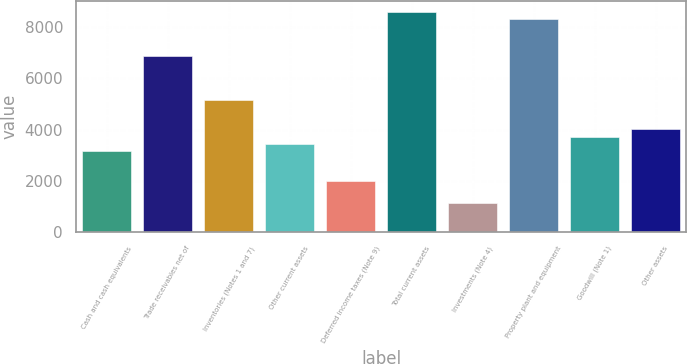<chart> <loc_0><loc_0><loc_500><loc_500><bar_chart><fcel>Cash and cash equivalents<fcel>Trade receivables net of<fcel>Inventories (Notes 1 and 7)<fcel>Other current assets<fcel>Deferred income taxes (Note 9)<fcel>Total current assets<fcel>Investments (Note 4)<fcel>Property plant and equipment<fcel>Goodwill (Note 1)<fcel>Other assets<nl><fcel>3158.77<fcel>6886.78<fcel>5166.16<fcel>3445.54<fcel>2011.69<fcel>8607.4<fcel>1151.38<fcel>8320.63<fcel>3732.31<fcel>4019.08<nl></chart> 